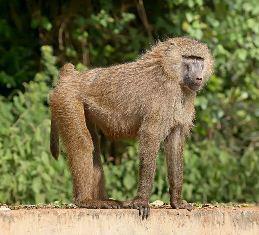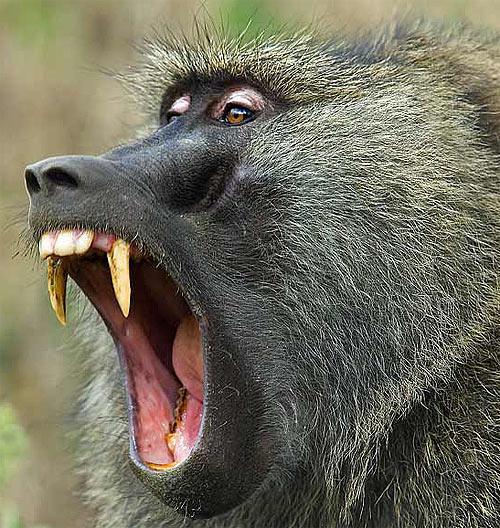The first image is the image on the left, the second image is the image on the right. Given the left and right images, does the statement "A baby monkey is with an adult monkey." hold true? Answer yes or no. No. 